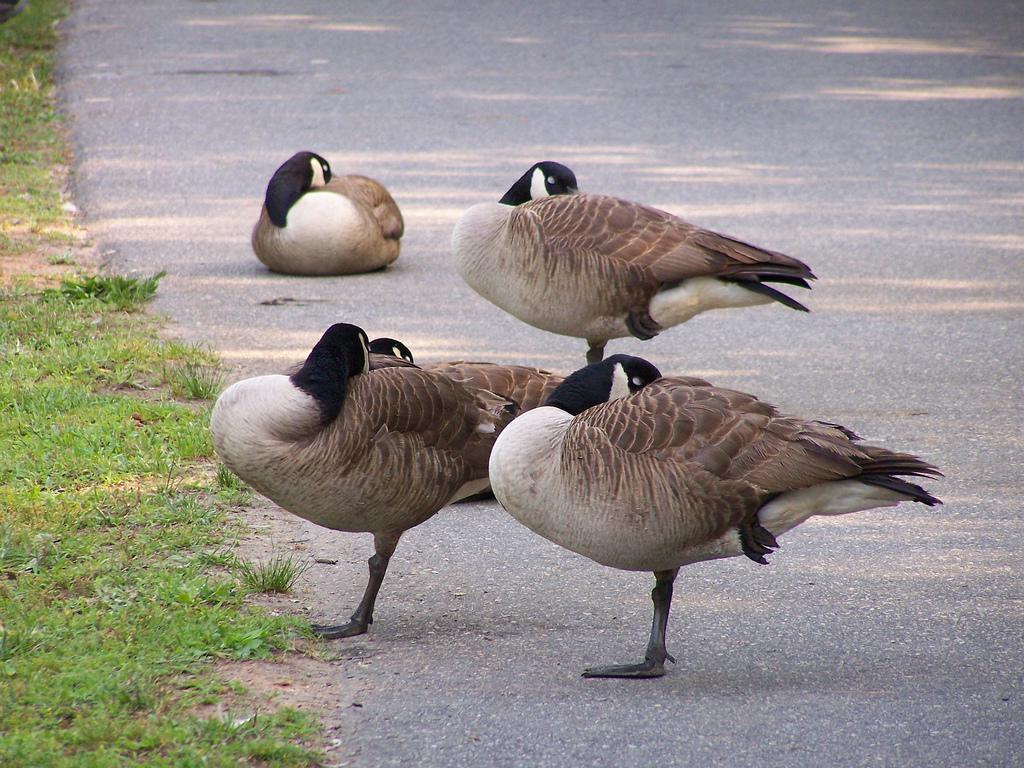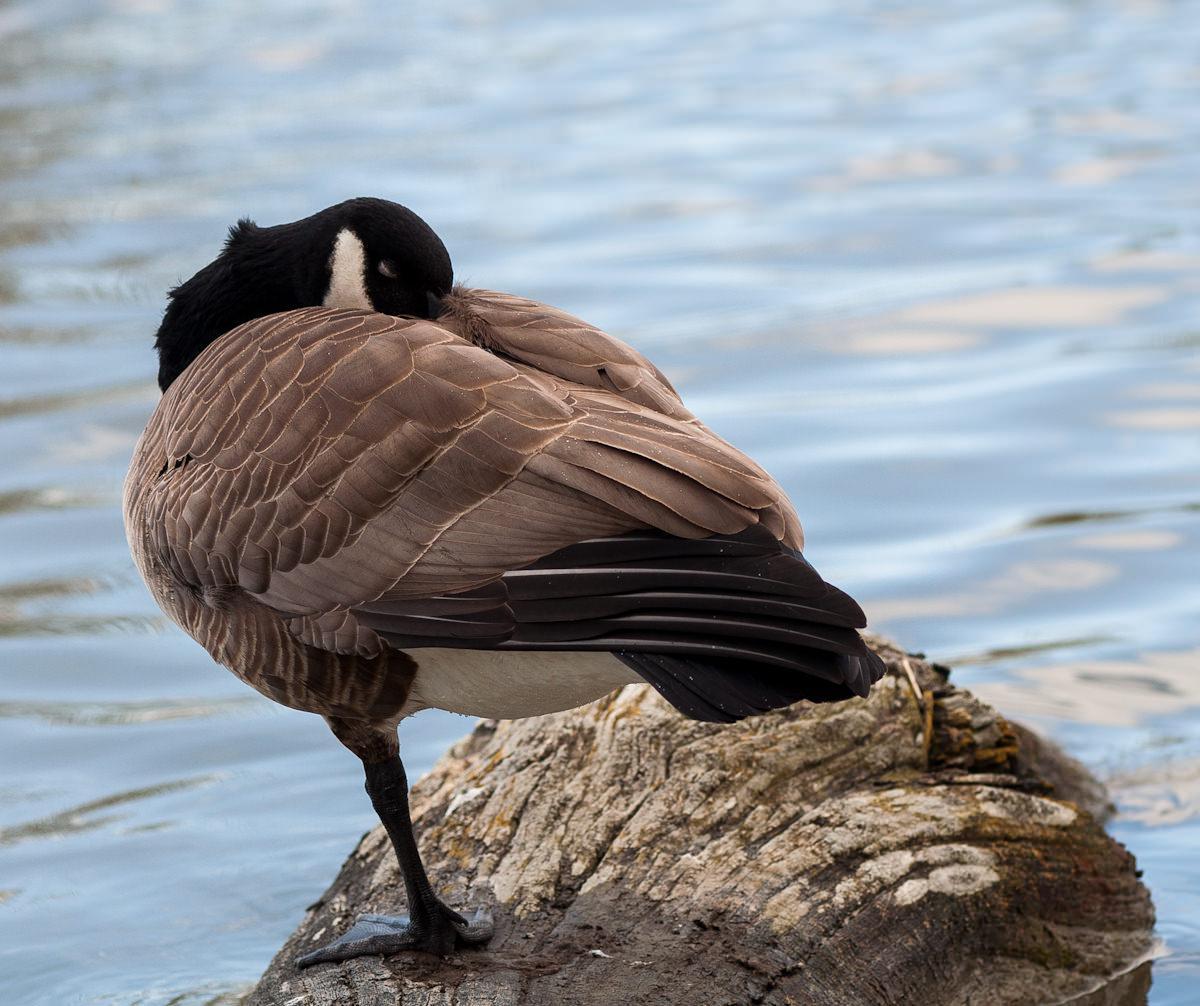The first image is the image on the left, the second image is the image on the right. For the images displayed, is the sentence "All the ducks are sleeping." factually correct? Answer yes or no. Yes. The first image is the image on the left, the second image is the image on the right. Analyze the images presented: Is the assertion "There are two birds in total." valid? Answer yes or no. No. 